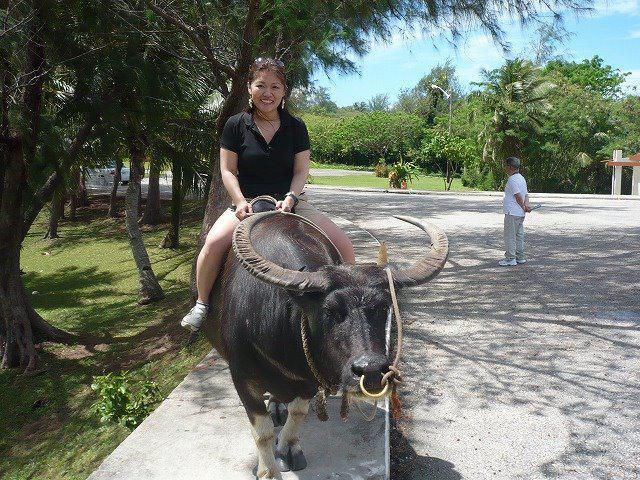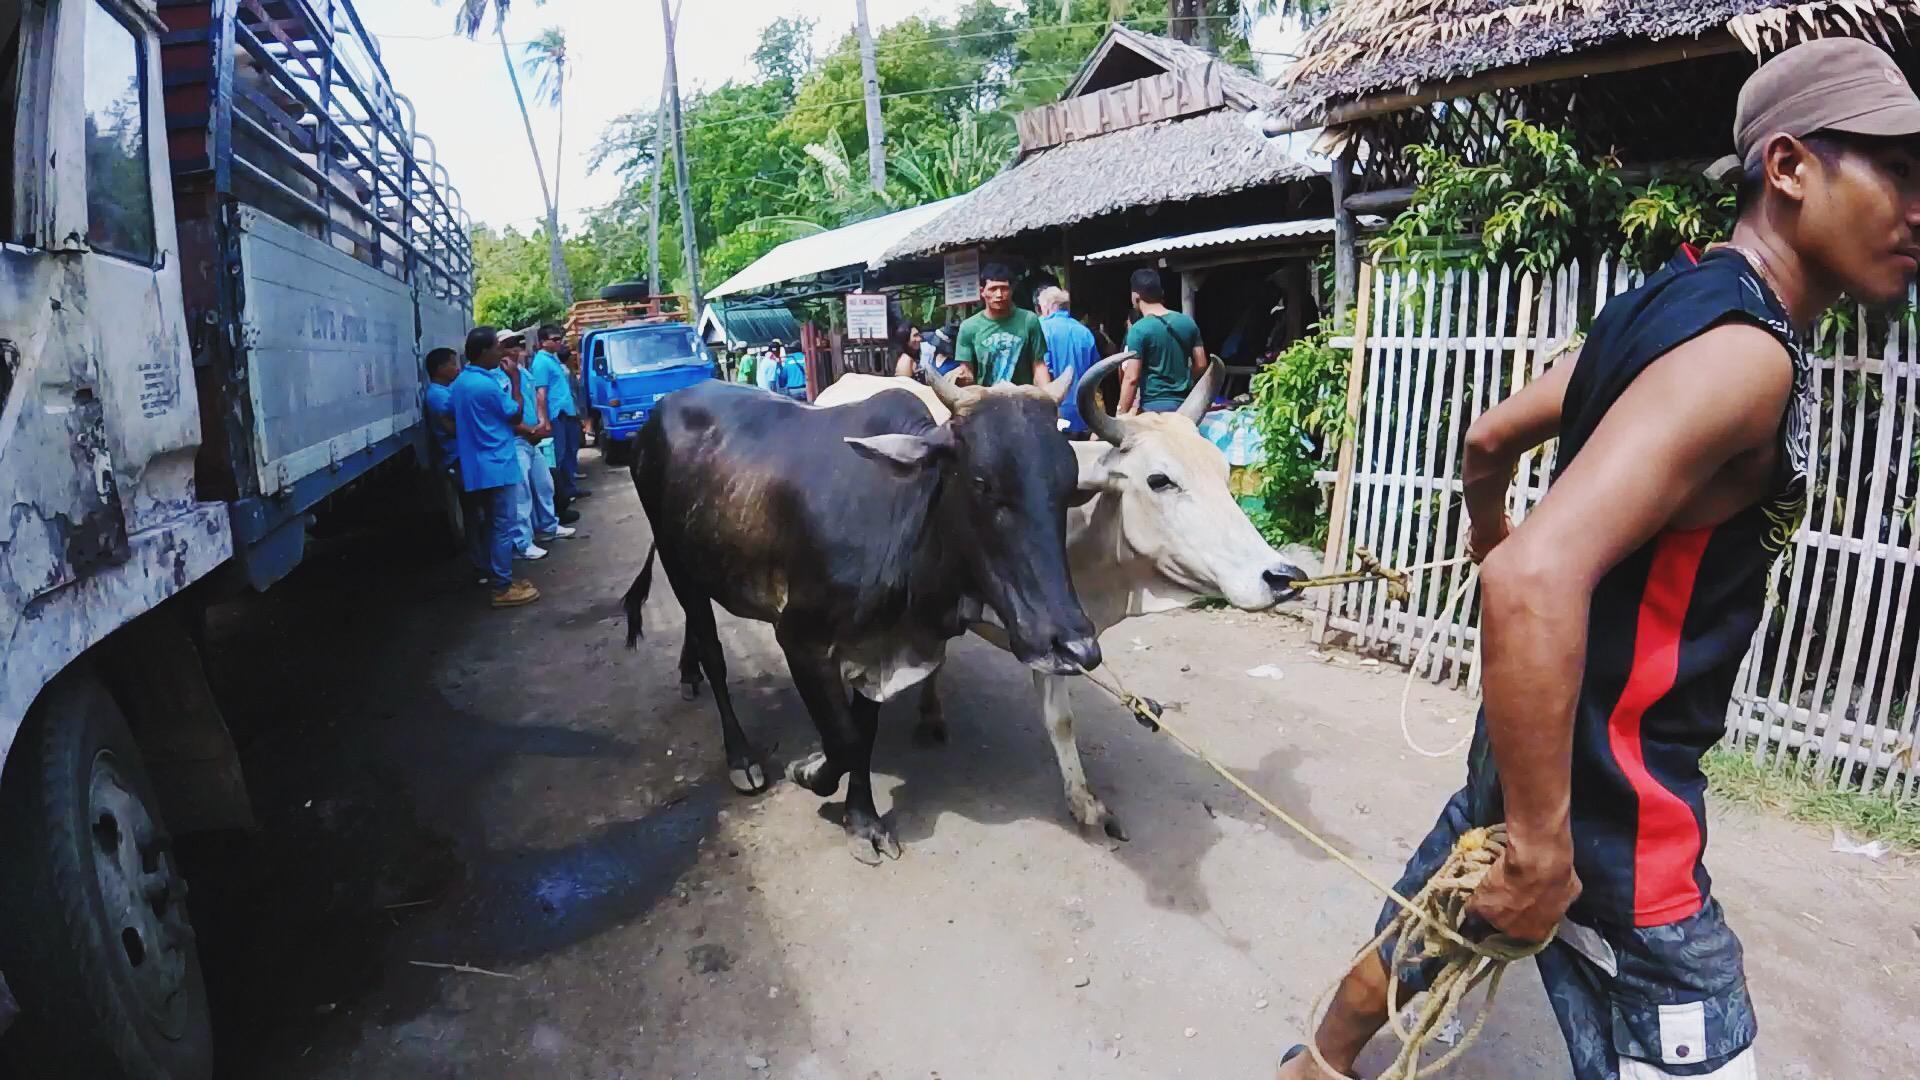The first image is the image on the left, the second image is the image on the right. Evaluate the accuracy of this statement regarding the images: "Each image features a race where a team of two water buffalo is driven forward by a man wielding a stick.". Is it true? Answer yes or no. No. The first image is the image on the left, the second image is the image on the right. Analyze the images presented: Is the assertion "Every single bovine appears to be part of a race." valid? Answer yes or no. No. 